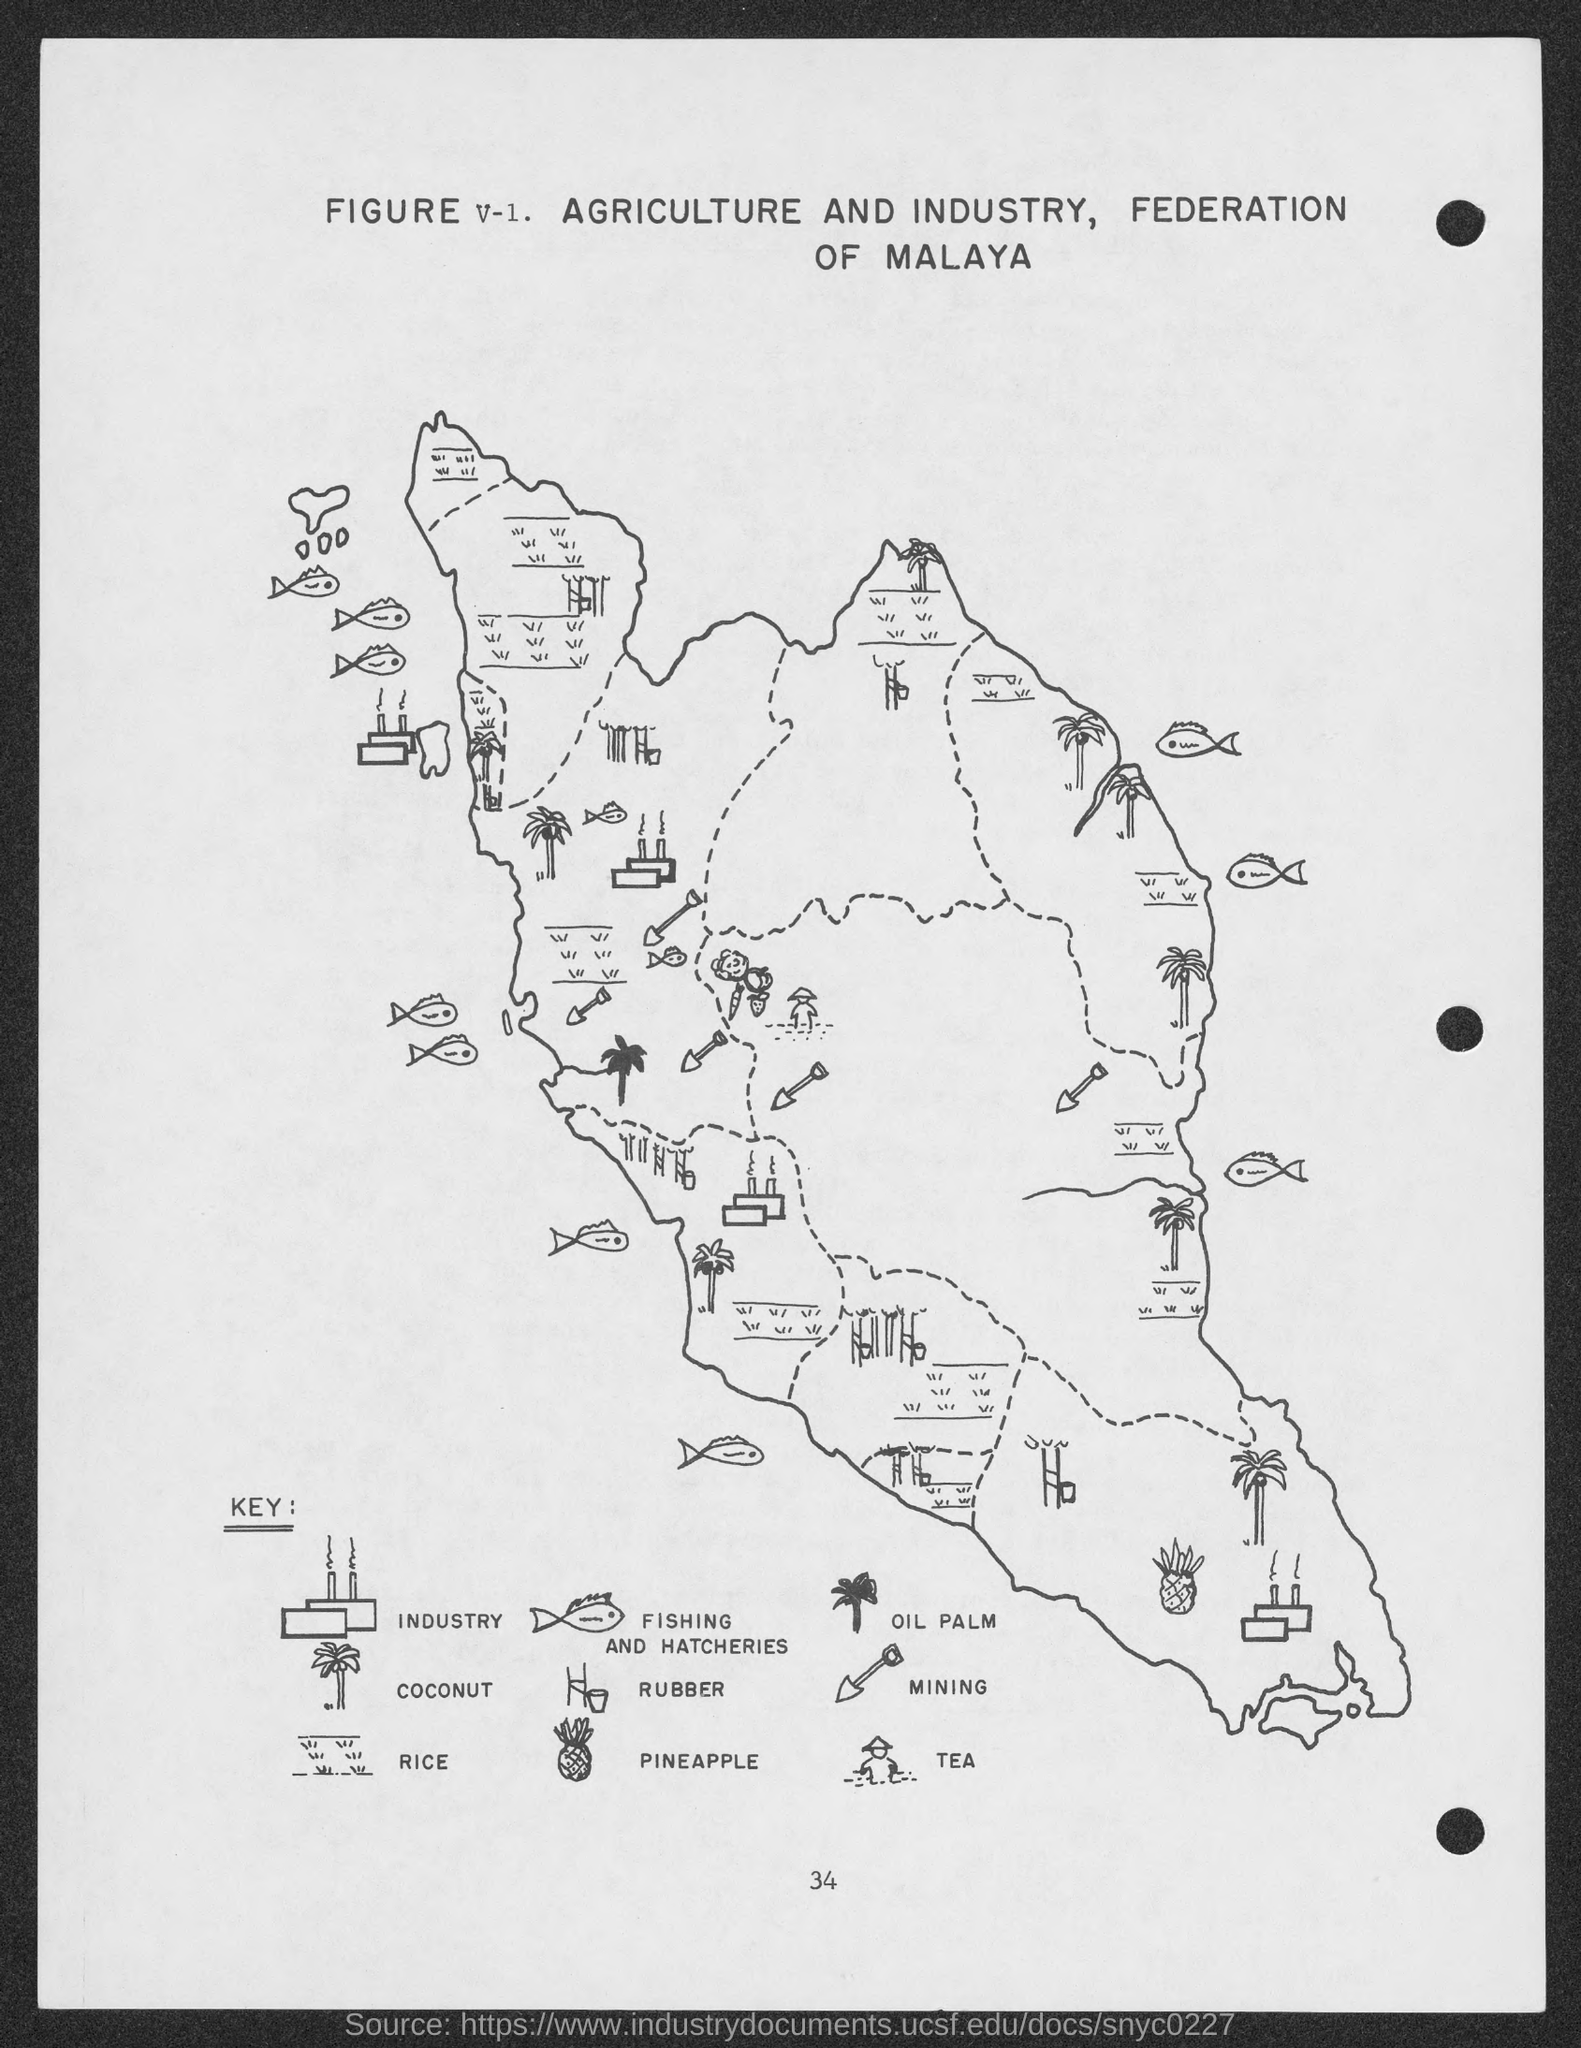Indicate a few pertinent items in this graphic. The number is V-1. The number at the bottom of the page is 34. 